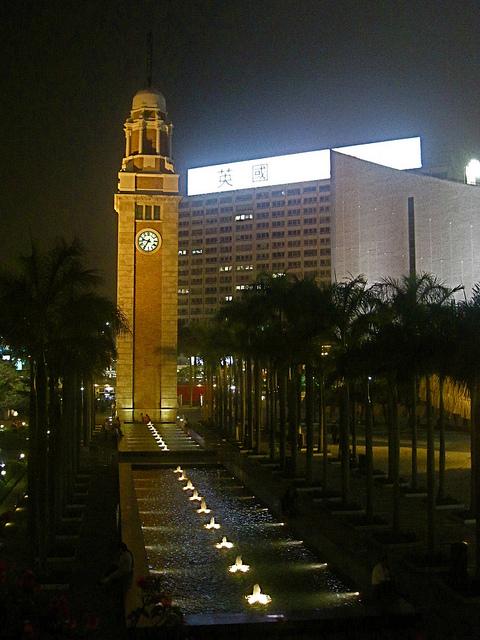What color are the lights above the clock?
Quick response, please. White. What time does the clock say?
Write a very short answer. 9:35. Is this a big palace?
Keep it brief. Yes. Is it night time?
Keep it brief. Yes. Are there kids around?
Be succinct. No. What time is it?
Keep it brief. 9:35. Is there water in the photo?
Write a very short answer. Yes. 